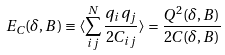Convert formula to latex. <formula><loc_0><loc_0><loc_500><loc_500>E _ { C } ( \delta , B ) \equiv \left < \sum _ { i j } ^ { N } \frac { q _ { i } q _ { j } } { 2 C _ { i j } } \right > = \frac { Q ^ { 2 } ( \delta , B ) } { 2 C ( \delta , B ) }</formula> 